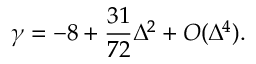Convert formula to latex. <formula><loc_0><loc_0><loc_500><loc_500>\gamma = - 8 + \frac { 3 1 } { 7 2 } \Delta ^ { 2 } + O ( \Delta ^ { 4 } ) .</formula> 